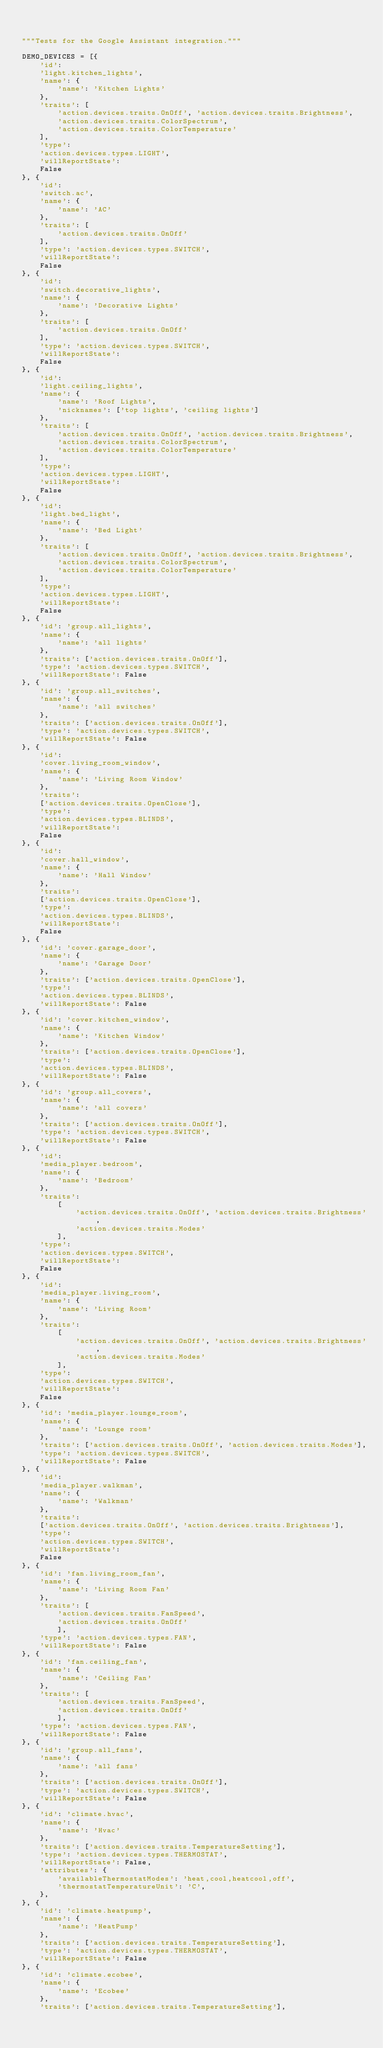<code> <loc_0><loc_0><loc_500><loc_500><_Python_>

"""Tests for the Google Assistant integration."""

DEMO_DEVICES = [{
    'id':
    'light.kitchen_lights',
    'name': {
        'name': 'Kitchen Lights'
    },
    'traits': [
        'action.devices.traits.OnOff', 'action.devices.traits.Brightness',
        'action.devices.traits.ColorSpectrum',
        'action.devices.traits.ColorTemperature'
    ],
    'type':
    'action.devices.types.LIGHT',
    'willReportState':
    False
}, {
    'id':
    'switch.ac',
    'name': {
        'name': 'AC'
    },
    'traits': [
        'action.devices.traits.OnOff'
    ],
    'type': 'action.devices.types.SWITCH',
    'willReportState':
    False
}, {
    'id':
    'switch.decorative_lights',
    'name': {
        'name': 'Decorative Lights'
    },
    'traits': [
        'action.devices.traits.OnOff'
    ],
    'type': 'action.devices.types.SWITCH',
    'willReportState':
    False
}, {
    'id':
    'light.ceiling_lights',
    'name': {
        'name': 'Roof Lights',
        'nicknames': ['top lights', 'ceiling lights']
    },
    'traits': [
        'action.devices.traits.OnOff', 'action.devices.traits.Brightness',
        'action.devices.traits.ColorSpectrum',
        'action.devices.traits.ColorTemperature'
    ],
    'type':
    'action.devices.types.LIGHT',
    'willReportState':
    False
}, {
    'id':
    'light.bed_light',
    'name': {
        'name': 'Bed Light'
    },
    'traits': [
        'action.devices.traits.OnOff', 'action.devices.traits.Brightness',
        'action.devices.traits.ColorSpectrum',
        'action.devices.traits.ColorTemperature'
    ],
    'type':
    'action.devices.types.LIGHT',
    'willReportState':
    False
}, {
    'id': 'group.all_lights',
    'name': {
        'name': 'all lights'
    },
    'traits': ['action.devices.traits.OnOff'],
    'type': 'action.devices.types.SWITCH',
    'willReportState': False
}, {
    'id': 'group.all_switches',
    'name': {
        'name': 'all switches'
    },
    'traits': ['action.devices.traits.OnOff'],
    'type': 'action.devices.types.SWITCH',
    'willReportState': False
}, {
    'id':
    'cover.living_room_window',
    'name': {
        'name': 'Living Room Window'
    },
    'traits':
    ['action.devices.traits.OpenClose'],
    'type':
    'action.devices.types.BLINDS',
    'willReportState':
    False
}, {
    'id':
    'cover.hall_window',
    'name': {
        'name': 'Hall Window'
    },
    'traits':
    ['action.devices.traits.OpenClose'],
    'type':
    'action.devices.types.BLINDS',
    'willReportState':
    False
}, {
    'id': 'cover.garage_door',
    'name': {
        'name': 'Garage Door'
    },
    'traits': ['action.devices.traits.OpenClose'],
    'type':
    'action.devices.types.BLINDS',
    'willReportState': False
}, {
    'id': 'cover.kitchen_window',
    'name': {
        'name': 'Kitchen Window'
    },
    'traits': ['action.devices.traits.OpenClose'],
    'type':
    'action.devices.types.BLINDS',
    'willReportState': False
}, {
    'id': 'group.all_covers',
    'name': {
        'name': 'all covers'
    },
    'traits': ['action.devices.traits.OnOff'],
    'type': 'action.devices.types.SWITCH',
    'willReportState': False
}, {
    'id':
    'media_player.bedroom',
    'name': {
        'name': 'Bedroom'
    },
    'traits':
        [
            'action.devices.traits.OnOff', 'action.devices.traits.Brightness',
            'action.devices.traits.Modes'
        ],
    'type':
    'action.devices.types.SWITCH',
    'willReportState':
    False
}, {
    'id':
    'media_player.living_room',
    'name': {
        'name': 'Living Room'
    },
    'traits':
        [
            'action.devices.traits.OnOff', 'action.devices.traits.Brightness',
            'action.devices.traits.Modes'
        ],
    'type':
    'action.devices.types.SWITCH',
    'willReportState':
    False
}, {
    'id': 'media_player.lounge_room',
    'name': {
        'name': 'Lounge room'
    },
    'traits': ['action.devices.traits.OnOff', 'action.devices.traits.Modes'],
    'type': 'action.devices.types.SWITCH',
    'willReportState': False
}, {
    'id':
    'media_player.walkman',
    'name': {
        'name': 'Walkman'
    },
    'traits':
    ['action.devices.traits.OnOff', 'action.devices.traits.Brightness'],
    'type':
    'action.devices.types.SWITCH',
    'willReportState':
    False
}, {
    'id': 'fan.living_room_fan',
    'name': {
        'name': 'Living Room Fan'
    },
    'traits': [
        'action.devices.traits.FanSpeed',
        'action.devices.traits.OnOff'
        ],
    'type': 'action.devices.types.FAN',
    'willReportState': False
}, {
    'id': 'fan.ceiling_fan',
    'name': {
        'name': 'Ceiling Fan'
    },
    'traits': [
        'action.devices.traits.FanSpeed',
        'action.devices.traits.OnOff'
        ],
    'type': 'action.devices.types.FAN',
    'willReportState': False
}, {
    'id': 'group.all_fans',
    'name': {
        'name': 'all fans'
    },
    'traits': ['action.devices.traits.OnOff'],
    'type': 'action.devices.types.SWITCH',
    'willReportState': False
}, {
    'id': 'climate.hvac',
    'name': {
        'name': 'Hvac'
    },
    'traits': ['action.devices.traits.TemperatureSetting'],
    'type': 'action.devices.types.THERMOSTAT',
    'willReportState': False,
    'attributes': {
        'availableThermostatModes': 'heat,cool,heatcool,off',
        'thermostatTemperatureUnit': 'C',
    },
}, {
    'id': 'climate.heatpump',
    'name': {
        'name': 'HeatPump'
    },
    'traits': ['action.devices.traits.TemperatureSetting'],
    'type': 'action.devices.types.THERMOSTAT',
    'willReportState': False
}, {
    'id': 'climate.ecobee',
    'name': {
        'name': 'Ecobee'
    },
    'traits': ['action.devices.traits.TemperatureSetting'],</code> 